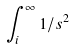<formula> <loc_0><loc_0><loc_500><loc_500>\int _ { i } ^ { \infty } 1 / s ^ { 2 }</formula> 